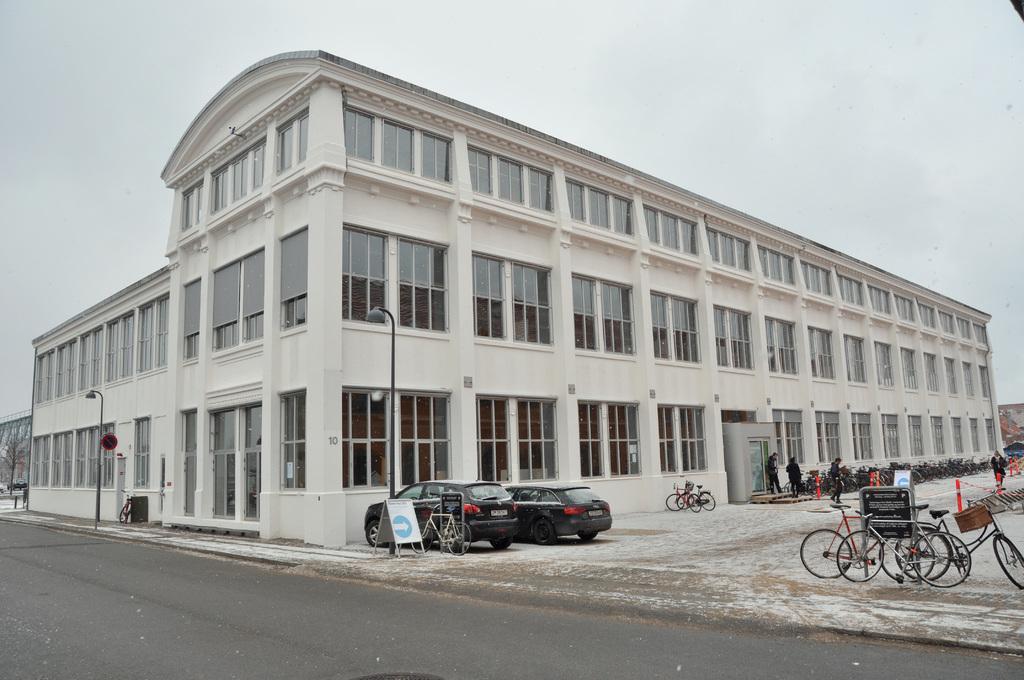Please provide a concise description of this image. In this image I can see few vehicles and I can see few people walking, light poles, buildings, few glass windows and the sky is in white color. 